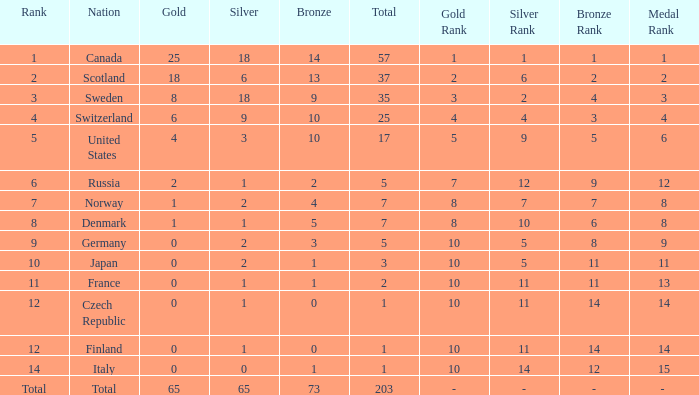What is the total number of medals when there are 18 gold medals? 37.0. Can you give me this table as a dict? {'header': ['Rank', 'Nation', 'Gold', 'Silver', 'Bronze', 'Total', 'Gold Rank', 'Silver Rank', 'Bronze Rank', 'Medal Rank'], 'rows': [['1', 'Canada', '25', '18', '14', '57', '1', '1', '1', '1'], ['2', 'Scotland', '18', '6', '13', '37', '2', '6', '2', '2'], ['3', 'Sweden', '8', '18', '9', '35', '3', '2', '4', '3'], ['4', 'Switzerland', '6', '9', '10', '25', '4', '4', '3', '4'], ['5', 'United States', '4', '3', '10', '17', '5', '9', '5', '6'], ['6', 'Russia', '2', '1', '2', '5', '7', '12', '9', '12'], ['7', 'Norway', '1', '2', '4', '7', '8', '7', '7', '8'], ['8', 'Denmark', '1', '1', '5', '7', '8', '10', '6', '8'], ['9', 'Germany', '0', '2', '3', '5', '10', '5', '8', '9'], ['10', 'Japan', '0', '2', '1', '3', '10', '5', '11', '11'], ['11', 'France', '0', '1', '1', '2', '10', '11', '11', '13'], ['12', 'Czech Republic', '0', '1', '0', '1', '10', '11', '14', '14'], ['12', 'Finland', '0', '1', '0', '1', '10', '11', '14', '14'], ['14', 'Italy', '0', '0', '1', '1', '10', '14', '12', '15'], ['Total', 'Total', '65', '65', '73', '203', '-', '-', '-', '- ']]} 